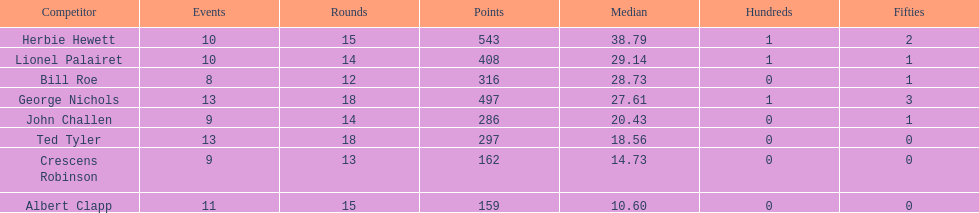Name a player that play in no more than 13 innings. Bill Roe. 